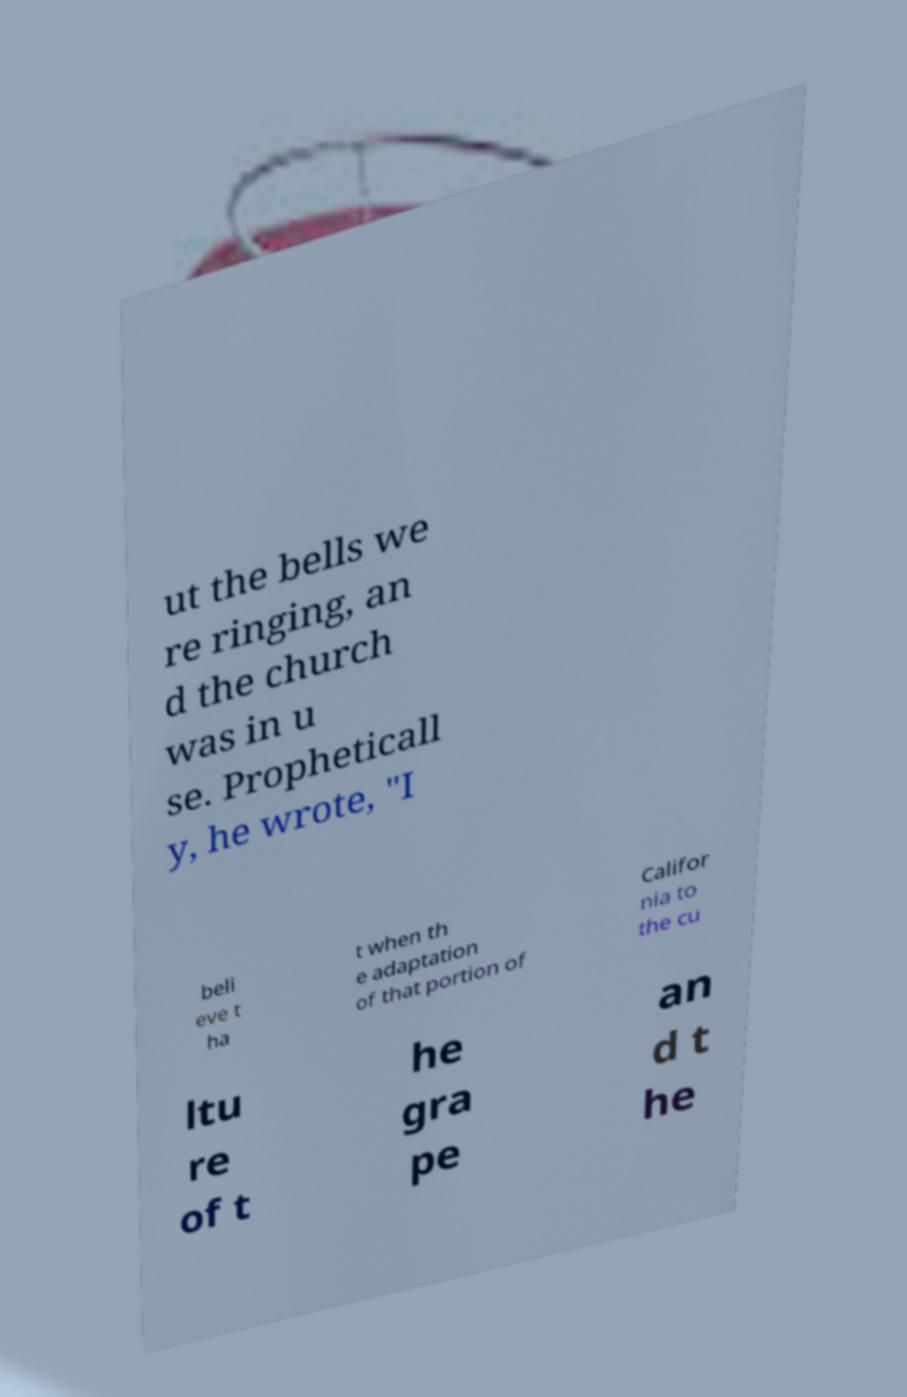What messages or text are displayed in this image? I need them in a readable, typed format. ut the bells we re ringing, an d the church was in u se. Propheticall y, he wrote, "I beli eve t ha t when th e adaptation of that portion of Califor nia to the cu ltu re of t he gra pe an d t he 